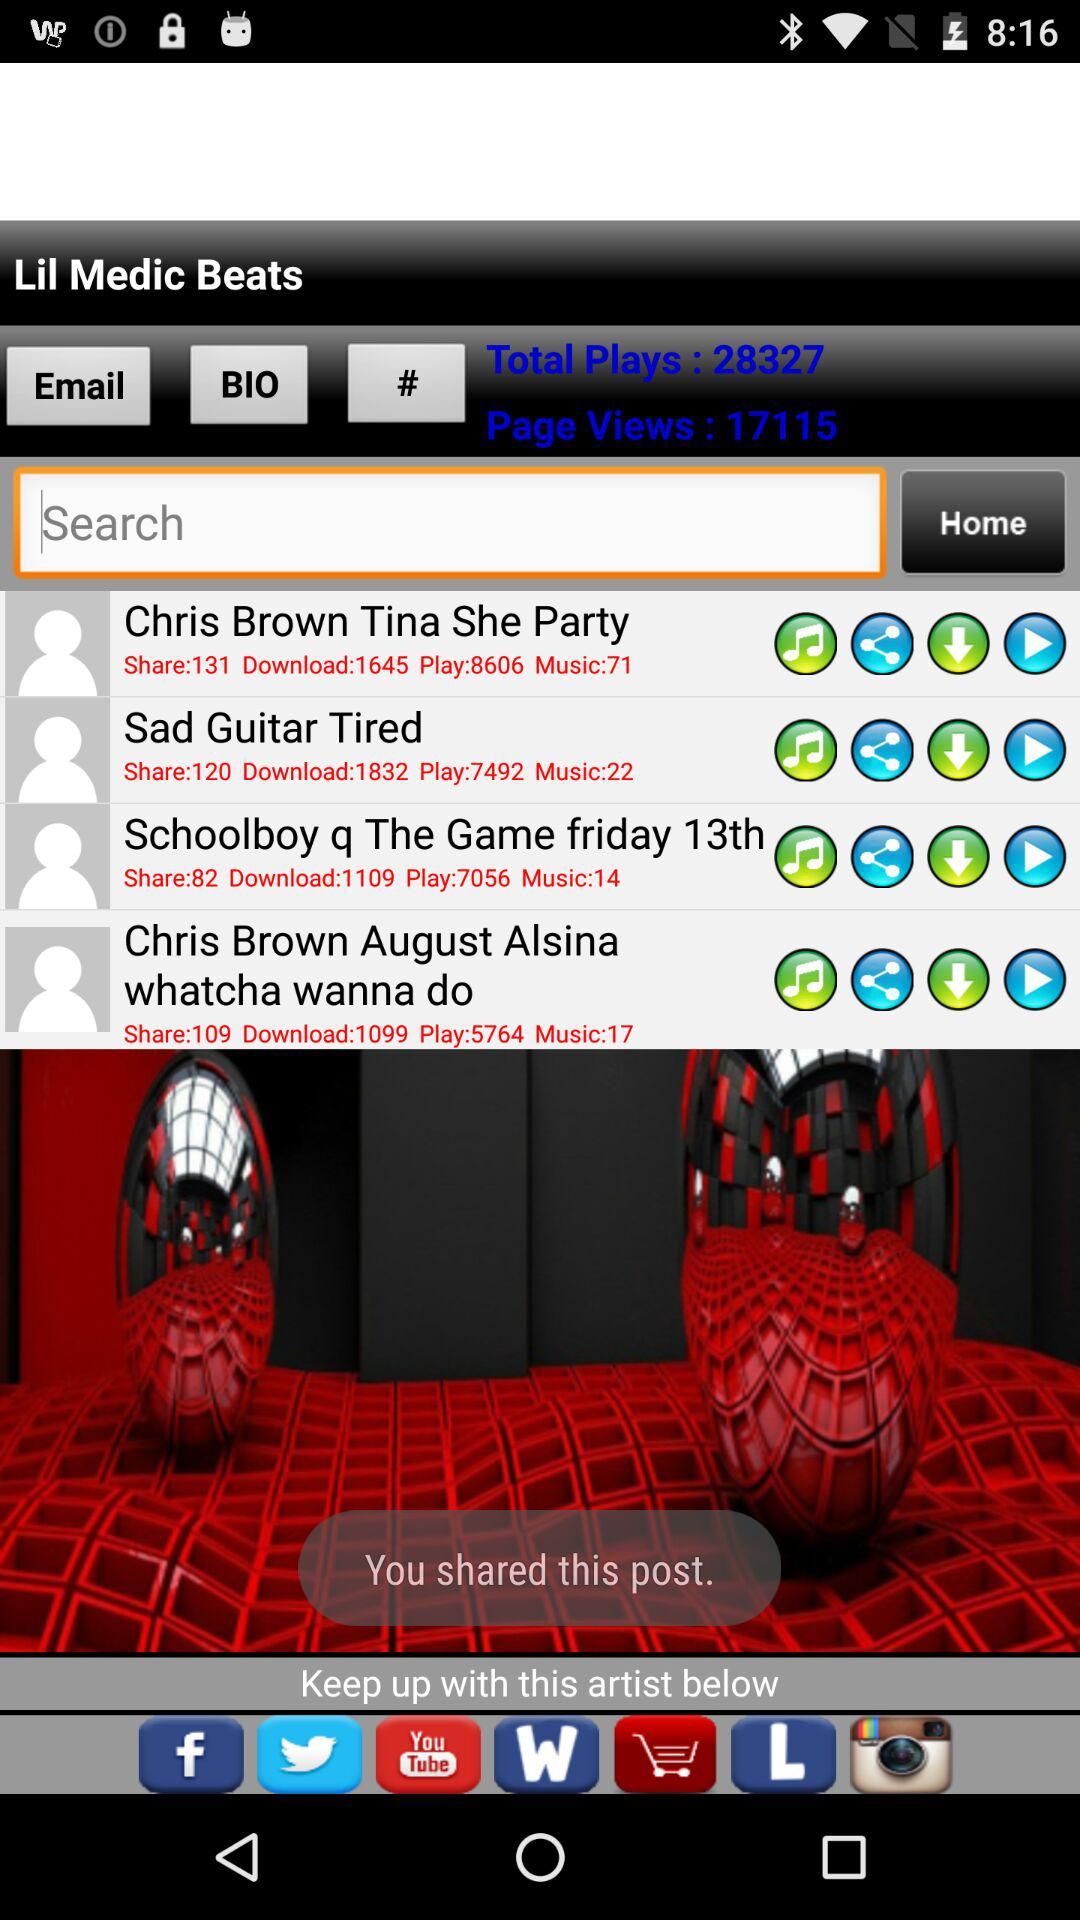What's the number of "Page Views"? The number of "Page Views" is 17115. 